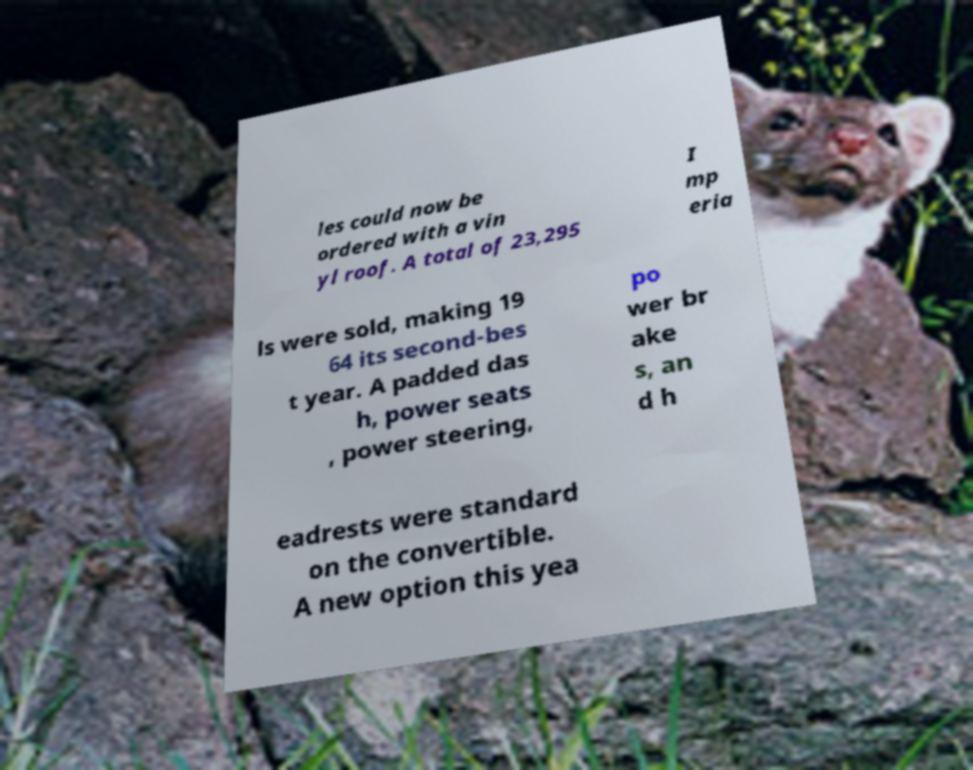Please read and relay the text visible in this image. What does it say? les could now be ordered with a vin yl roof. A total of 23,295 I mp eria ls were sold, making 19 64 its second-bes t year. A padded das h, power seats , power steering, po wer br ake s, an d h eadrests were standard on the convertible. A new option this yea 